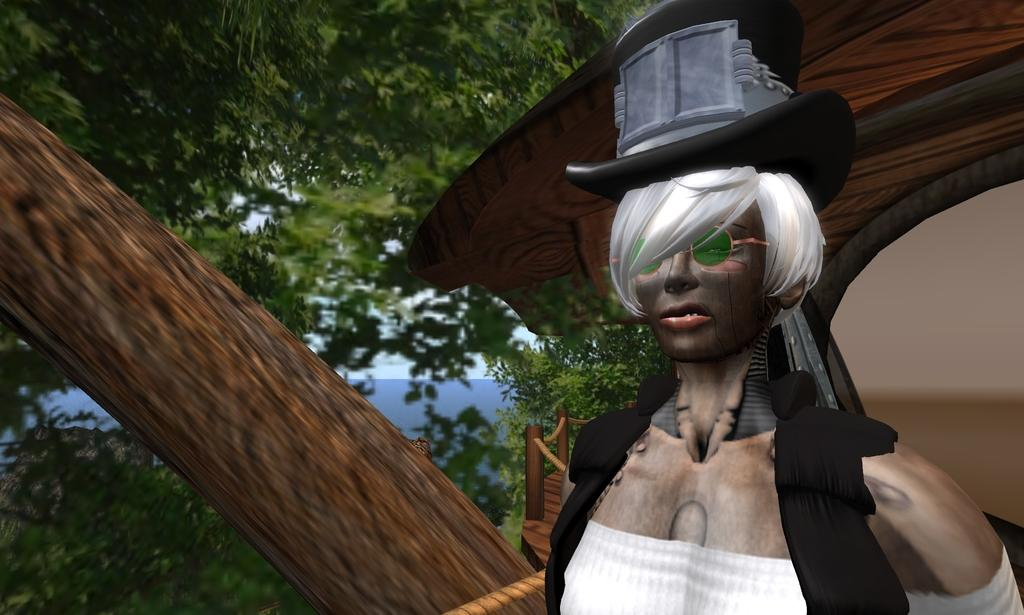What type of image is in the foreground of the picture? There is an animated image of a person in the image. What can be seen in the background of the image? There are trees, wooden sticks, an arch, and the sky visible in the background of the image. What type of pickle is the farmer holding in the image? There is no farmer or pickle present in the image. Can you describe the veins in the image? There are no veins visible in the image; it features an animated person, trees, wooden sticks, an arch, and the sky. 